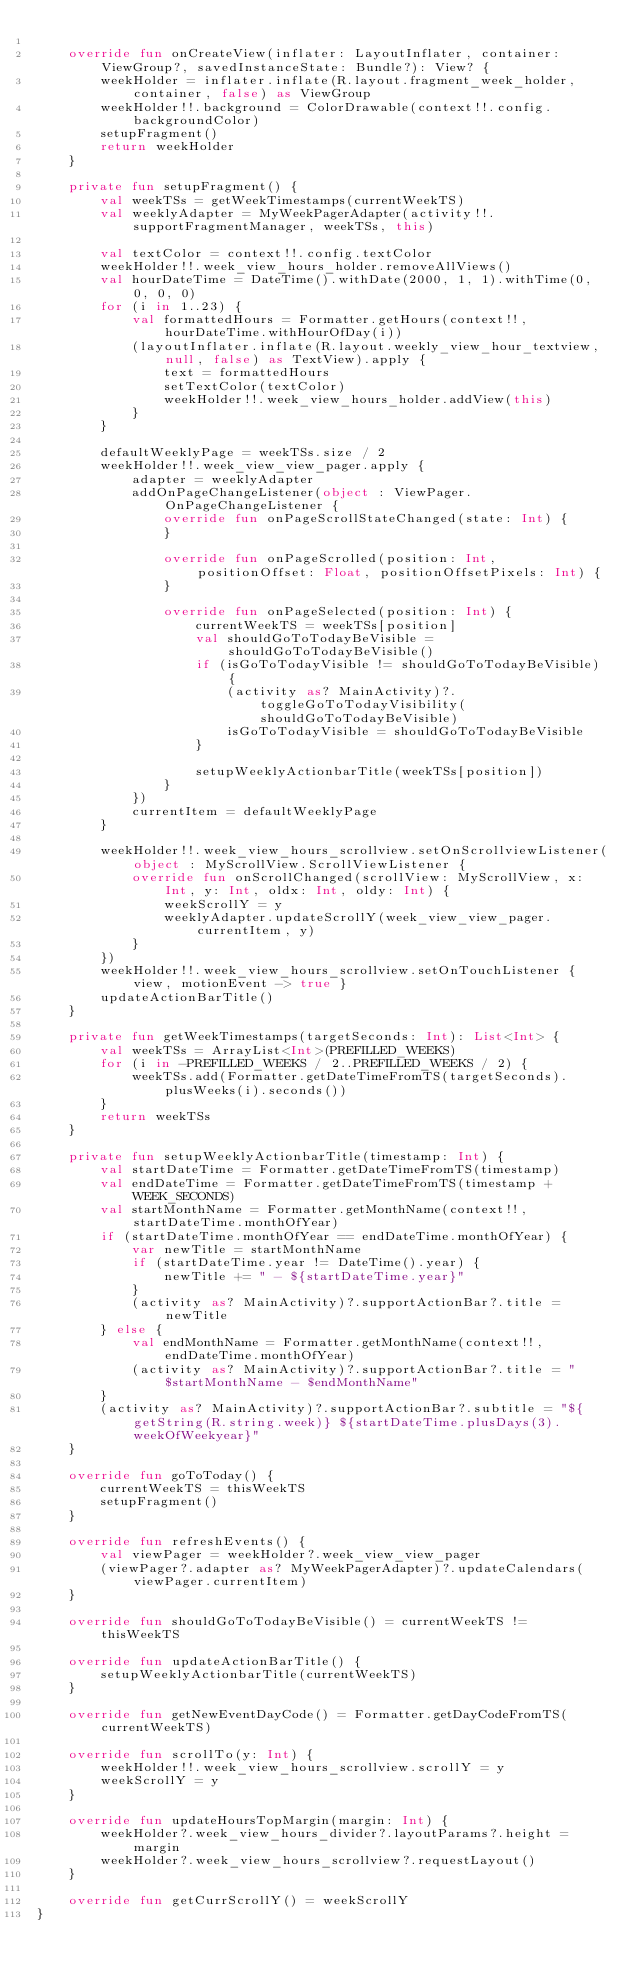<code> <loc_0><loc_0><loc_500><loc_500><_Kotlin_>
    override fun onCreateView(inflater: LayoutInflater, container: ViewGroup?, savedInstanceState: Bundle?): View? {
        weekHolder = inflater.inflate(R.layout.fragment_week_holder, container, false) as ViewGroup
        weekHolder!!.background = ColorDrawable(context!!.config.backgroundColor)
        setupFragment()
        return weekHolder
    }

    private fun setupFragment() {
        val weekTSs = getWeekTimestamps(currentWeekTS)
        val weeklyAdapter = MyWeekPagerAdapter(activity!!.supportFragmentManager, weekTSs, this)

        val textColor = context!!.config.textColor
        weekHolder!!.week_view_hours_holder.removeAllViews()
        val hourDateTime = DateTime().withDate(2000, 1, 1).withTime(0, 0, 0, 0)
        for (i in 1..23) {
            val formattedHours = Formatter.getHours(context!!, hourDateTime.withHourOfDay(i))
            (layoutInflater.inflate(R.layout.weekly_view_hour_textview, null, false) as TextView).apply {
                text = formattedHours
                setTextColor(textColor)
                weekHolder!!.week_view_hours_holder.addView(this)
            }
        }

        defaultWeeklyPage = weekTSs.size / 2
        weekHolder!!.week_view_view_pager.apply {
            adapter = weeklyAdapter
            addOnPageChangeListener(object : ViewPager.OnPageChangeListener {
                override fun onPageScrollStateChanged(state: Int) {
                }

                override fun onPageScrolled(position: Int, positionOffset: Float, positionOffsetPixels: Int) {
                }

                override fun onPageSelected(position: Int) {
                    currentWeekTS = weekTSs[position]
                    val shouldGoToTodayBeVisible = shouldGoToTodayBeVisible()
                    if (isGoToTodayVisible != shouldGoToTodayBeVisible) {
                        (activity as? MainActivity)?.toggleGoToTodayVisibility(shouldGoToTodayBeVisible)
                        isGoToTodayVisible = shouldGoToTodayBeVisible
                    }

                    setupWeeklyActionbarTitle(weekTSs[position])
                }
            })
            currentItem = defaultWeeklyPage
        }

        weekHolder!!.week_view_hours_scrollview.setOnScrollviewListener(object : MyScrollView.ScrollViewListener {
            override fun onScrollChanged(scrollView: MyScrollView, x: Int, y: Int, oldx: Int, oldy: Int) {
                weekScrollY = y
                weeklyAdapter.updateScrollY(week_view_view_pager.currentItem, y)
            }
        })
        weekHolder!!.week_view_hours_scrollview.setOnTouchListener { view, motionEvent -> true }
        updateActionBarTitle()
    }

    private fun getWeekTimestamps(targetSeconds: Int): List<Int> {
        val weekTSs = ArrayList<Int>(PREFILLED_WEEKS)
        for (i in -PREFILLED_WEEKS / 2..PREFILLED_WEEKS / 2) {
            weekTSs.add(Formatter.getDateTimeFromTS(targetSeconds).plusWeeks(i).seconds())
        }
        return weekTSs
    }

    private fun setupWeeklyActionbarTitle(timestamp: Int) {
        val startDateTime = Formatter.getDateTimeFromTS(timestamp)
        val endDateTime = Formatter.getDateTimeFromTS(timestamp + WEEK_SECONDS)
        val startMonthName = Formatter.getMonthName(context!!, startDateTime.monthOfYear)
        if (startDateTime.monthOfYear == endDateTime.monthOfYear) {
            var newTitle = startMonthName
            if (startDateTime.year != DateTime().year) {
                newTitle += " - ${startDateTime.year}"
            }
            (activity as? MainActivity)?.supportActionBar?.title = newTitle
        } else {
            val endMonthName = Formatter.getMonthName(context!!, endDateTime.monthOfYear)
            (activity as? MainActivity)?.supportActionBar?.title = "$startMonthName - $endMonthName"
        }
        (activity as? MainActivity)?.supportActionBar?.subtitle = "${getString(R.string.week)} ${startDateTime.plusDays(3).weekOfWeekyear}"
    }

    override fun goToToday() {
        currentWeekTS = thisWeekTS
        setupFragment()
    }

    override fun refreshEvents() {
        val viewPager = weekHolder?.week_view_view_pager
        (viewPager?.adapter as? MyWeekPagerAdapter)?.updateCalendars(viewPager.currentItem)
    }

    override fun shouldGoToTodayBeVisible() = currentWeekTS != thisWeekTS

    override fun updateActionBarTitle() {
        setupWeeklyActionbarTitle(currentWeekTS)
    }

    override fun getNewEventDayCode() = Formatter.getDayCodeFromTS(currentWeekTS)

    override fun scrollTo(y: Int) {
        weekHolder!!.week_view_hours_scrollview.scrollY = y
        weekScrollY = y
    }

    override fun updateHoursTopMargin(margin: Int) {
        weekHolder?.week_view_hours_divider?.layoutParams?.height = margin
        weekHolder?.week_view_hours_scrollview?.requestLayout()
    }

    override fun getCurrScrollY() = weekScrollY
}
</code> 